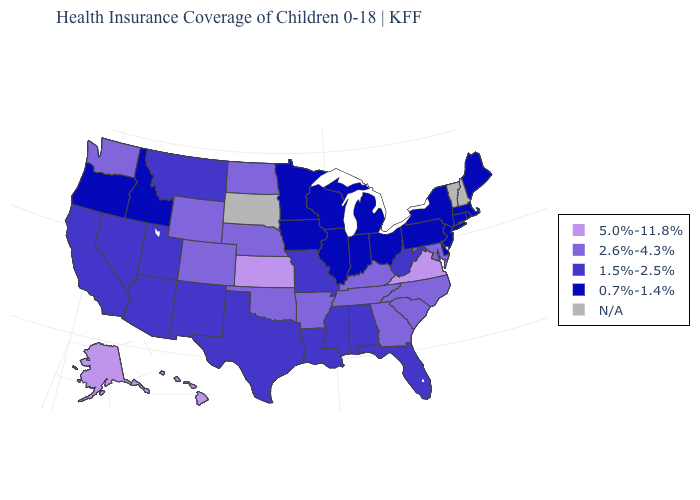Name the states that have a value in the range N/A?
Concise answer only. New Hampshire, South Dakota, Vermont. What is the lowest value in the USA?
Be succinct. 0.7%-1.4%. What is the value of Maryland?
Answer briefly. 2.6%-4.3%. Does Arkansas have the highest value in the South?
Concise answer only. No. Which states have the highest value in the USA?
Short answer required. Alaska, Hawaii, Kansas, Virginia. Which states have the highest value in the USA?
Be succinct. Alaska, Hawaii, Kansas, Virginia. What is the value of Connecticut?
Write a very short answer. 0.7%-1.4%. Which states have the lowest value in the West?
Short answer required. Idaho, Oregon. Name the states that have a value in the range 2.6%-4.3%?
Write a very short answer. Arkansas, Colorado, Georgia, Kentucky, Maryland, Nebraska, North Carolina, North Dakota, Oklahoma, South Carolina, Tennessee, Washington, Wyoming. Which states hav the highest value in the West?
Quick response, please. Alaska, Hawaii. What is the value of Arizona?
Quick response, please. 1.5%-2.5%. What is the value of Georgia?
Concise answer only. 2.6%-4.3%. Name the states that have a value in the range 1.5%-2.5%?
Quick response, please. Alabama, Arizona, California, Florida, Louisiana, Mississippi, Missouri, Montana, Nevada, New Mexico, Texas, Utah, West Virginia. What is the value of Arizona?
Keep it brief. 1.5%-2.5%. 